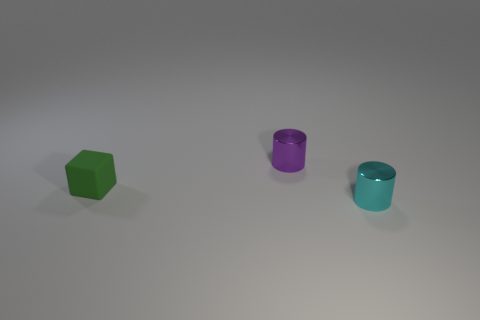Are there any tiny cylinders?
Your answer should be very brief. Yes. There is a thing that is right of the small matte object and in front of the purple object; what size is it?
Offer a terse response. Small. What is the shape of the green thing?
Your response must be concise. Cube. There is a object that is to the left of the small purple metal cylinder; are there any tiny green matte cubes that are on the left side of it?
Offer a terse response. No. What material is the purple object that is the same size as the green rubber object?
Offer a terse response. Metal. Is there a yellow metallic sphere of the same size as the matte object?
Your response must be concise. No. There is a small cylinder that is behind the cyan metallic thing; what is it made of?
Your response must be concise. Metal. Is the tiny cylinder behind the small block made of the same material as the cyan object?
Provide a succinct answer. Yes. There is a purple thing that is the same size as the rubber block; what shape is it?
Offer a terse response. Cylinder. Is the number of tiny cyan things that are behind the tiny cyan metal thing less than the number of tiny shiny objects that are in front of the small green rubber cube?
Your answer should be compact. Yes. 